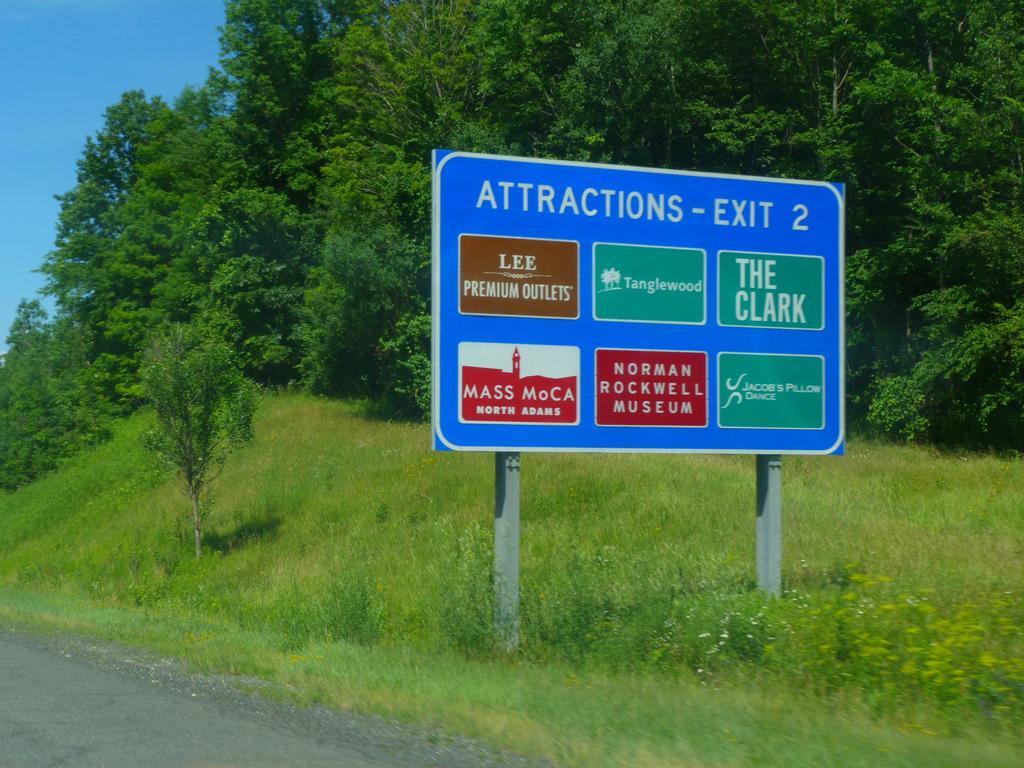What is found on exit two?
Keep it short and to the point. Attractions. What does it say in the green box on top right?
Keep it short and to the point. The clark. 